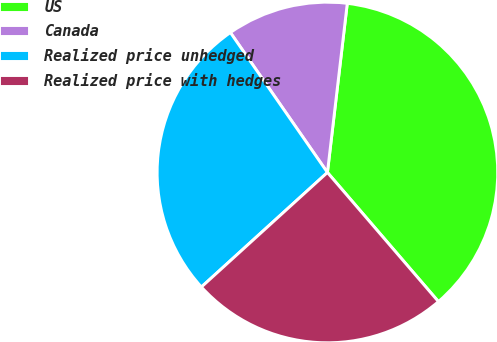Convert chart to OTSL. <chart><loc_0><loc_0><loc_500><loc_500><pie_chart><fcel>US<fcel>Canada<fcel>Realized price unhedged<fcel>Realized price with hedges<nl><fcel>36.84%<fcel>11.51%<fcel>27.09%<fcel>24.56%<nl></chart> 